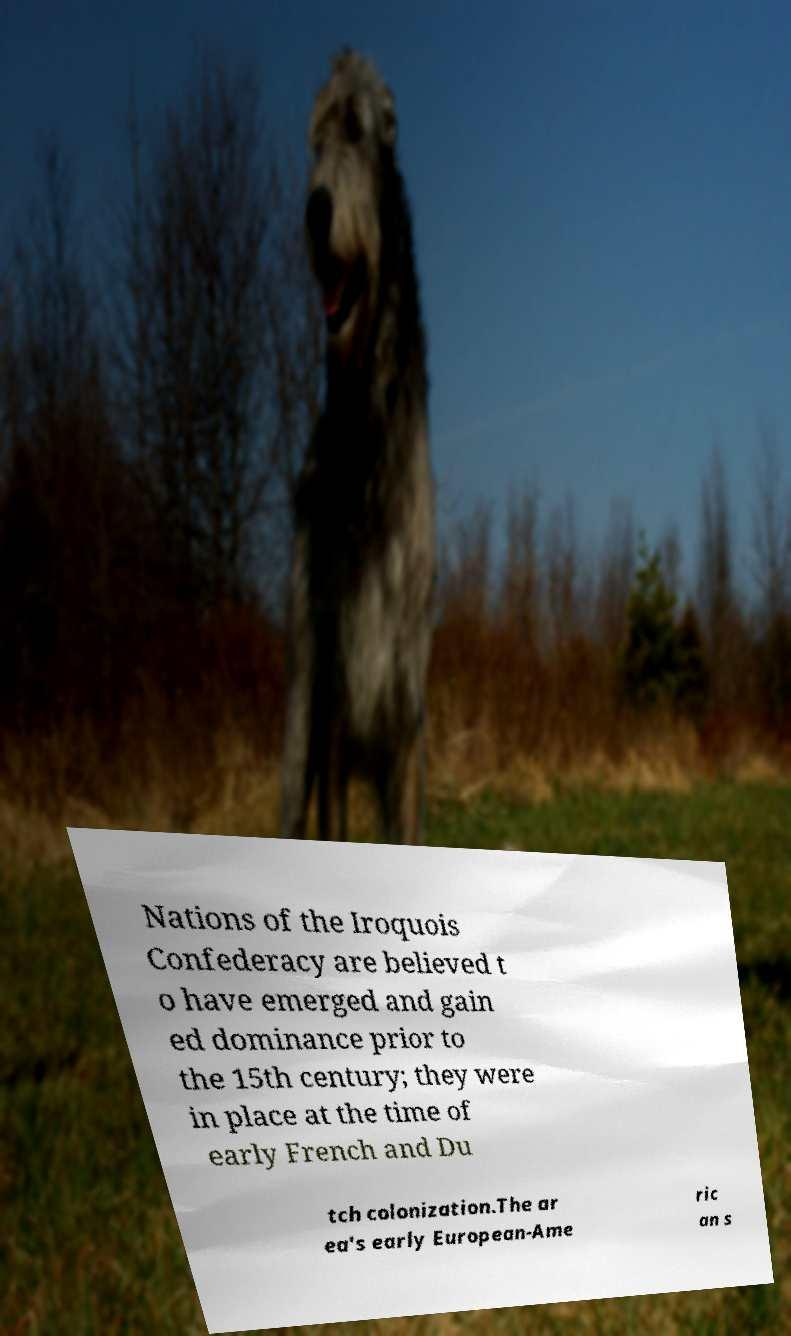Please identify and transcribe the text found in this image. Nations of the Iroquois Confederacy are believed t o have emerged and gain ed dominance prior to the 15th century; they were in place at the time of early French and Du tch colonization.The ar ea's early European-Ame ric an s 